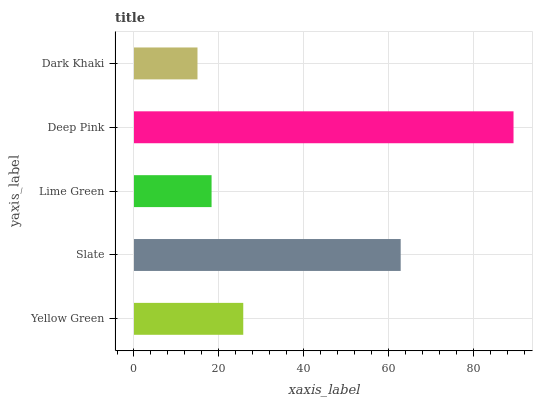Is Dark Khaki the minimum?
Answer yes or no. Yes. Is Deep Pink the maximum?
Answer yes or no. Yes. Is Slate the minimum?
Answer yes or no. No. Is Slate the maximum?
Answer yes or no. No. Is Slate greater than Yellow Green?
Answer yes or no. Yes. Is Yellow Green less than Slate?
Answer yes or no. Yes. Is Yellow Green greater than Slate?
Answer yes or no. No. Is Slate less than Yellow Green?
Answer yes or no. No. Is Yellow Green the high median?
Answer yes or no. Yes. Is Yellow Green the low median?
Answer yes or no. Yes. Is Deep Pink the high median?
Answer yes or no. No. Is Deep Pink the low median?
Answer yes or no. No. 